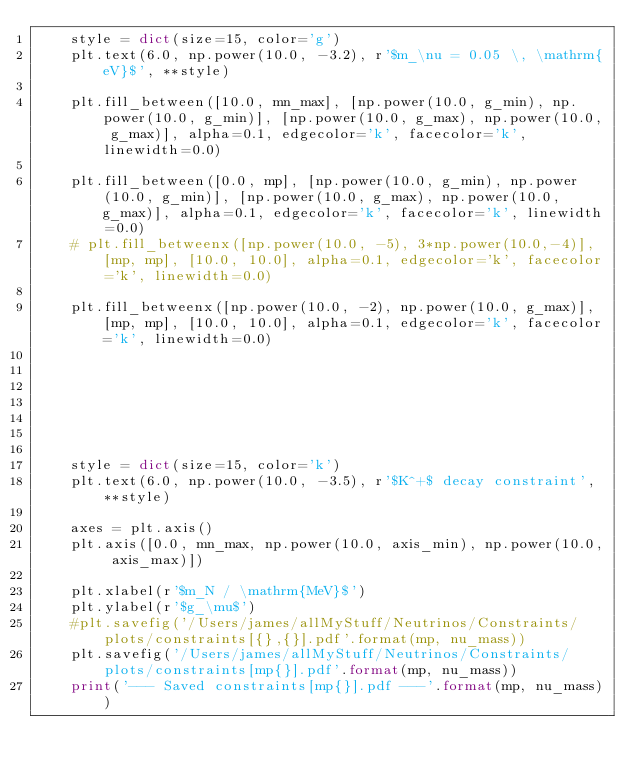Convert code to text. <code><loc_0><loc_0><loc_500><loc_500><_Python_>	style = dict(size=15, color='g')
	plt.text(6.0, np.power(10.0, -3.2), r'$m_\nu = 0.05 \, \mathrm{eV}$', **style)

	plt.fill_between([10.0, mn_max], [np.power(10.0, g_min), np.power(10.0, g_min)], [np.power(10.0, g_max), np.power(10.0, g_max)], alpha=0.1, edgecolor='k', facecolor='k', linewidth=0.0)

	plt.fill_between([0.0, mp], [np.power(10.0, g_min), np.power(10.0, g_min)], [np.power(10.0, g_max), np.power(10.0, g_max)], alpha=0.1, edgecolor='k', facecolor='k', linewidth=0.0)
	# plt.fill_betweenx([np.power(10.0, -5), 3*np.power(10.0,-4)], [mp, mp], [10.0, 10.0], alpha=0.1, edgecolor='k', facecolor='k', linewidth=0.0)

	plt.fill_betweenx([np.power(10.0, -2), np.power(10.0, g_max)], [mp, mp], [10.0, 10.0], alpha=0.1, edgecolor='k', facecolor='k', linewidth=0.0)







	style = dict(size=15, color='k')
	plt.text(6.0, np.power(10.0, -3.5), r'$K^+$ decay constraint', **style)

	axes = plt.axis()
	plt.axis([0.0, mn_max, np.power(10.0, axis_min), np.power(10.0, axis_max)])

	plt.xlabel(r'$m_N / \mathrm{MeV}$')
	plt.ylabel(r'$g_\mu$')
	#plt.savefig('/Users/james/allMyStuff/Neutrinos/Constraints/plots/constraints[{},{}].pdf'.format(mp, nu_mass))
	plt.savefig('/Users/james/allMyStuff/Neutrinos/Constraints/plots/constraints[mp{}].pdf'.format(mp, nu_mass))
	print('--- Saved constraints[mp{}].pdf ---'.format(mp, nu_mass))
</code> 